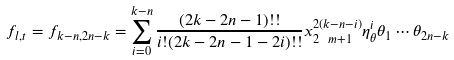Convert formula to latex. <formula><loc_0><loc_0><loc_500><loc_500>f _ { l , t } = f _ { k - n , 2 n - k } = \sum _ { i = 0 } ^ { k - n } \frac { ( 2 k - 2 n - 1 ) ! ! } { i ! ( 2 k - 2 n - 1 - 2 i ) ! ! } x _ { 2 \ m + 1 } ^ { 2 ( k - n - i ) } \eta _ { \theta } ^ { i } \theta _ { 1 } \cdots \theta _ { 2 n - k }</formula> 